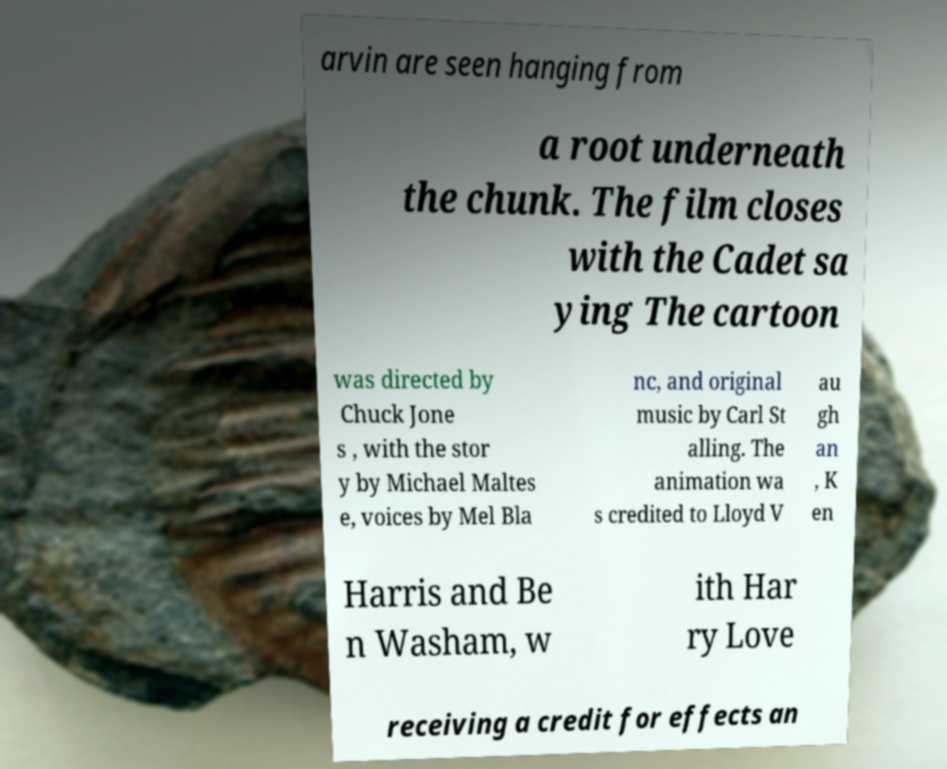Could you assist in decoding the text presented in this image and type it out clearly? arvin are seen hanging from a root underneath the chunk. The film closes with the Cadet sa ying The cartoon was directed by Chuck Jone s , with the stor y by Michael Maltes e, voices by Mel Bla nc, and original music by Carl St alling. The animation wa s credited to Lloyd V au gh an , K en Harris and Be n Washam, w ith Har ry Love receiving a credit for effects an 